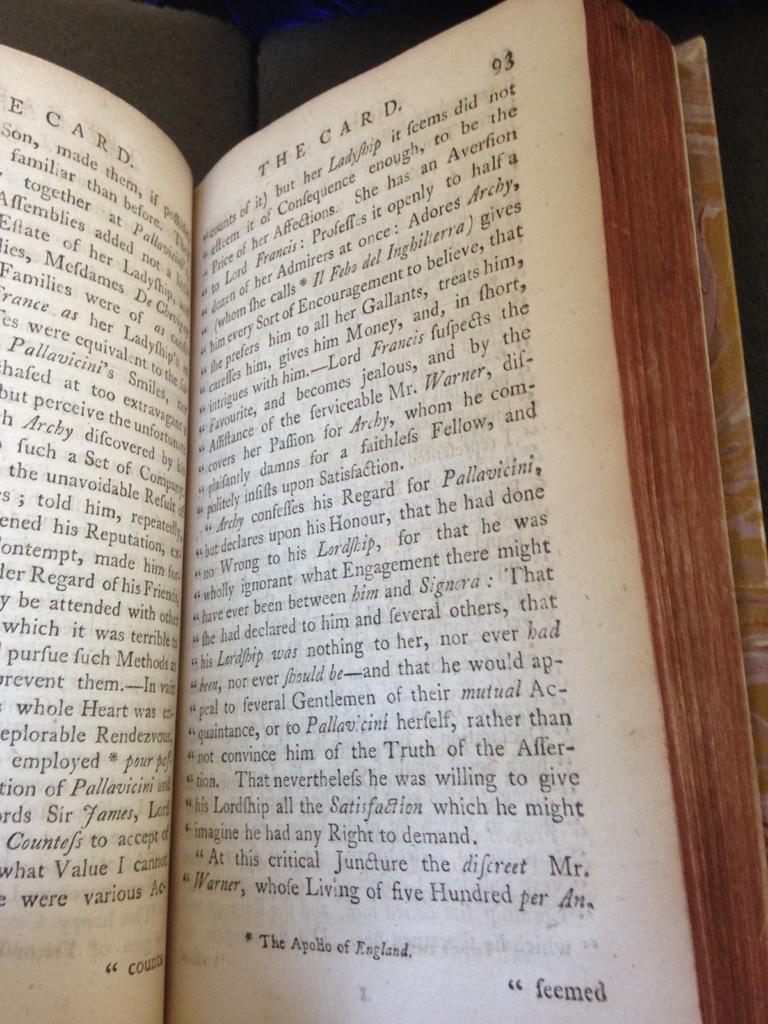What page number is on the right?
Offer a very short reply. 93. 